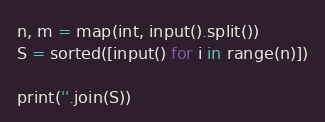Convert code to text. <code><loc_0><loc_0><loc_500><loc_500><_Python_>n, m = map(int, input().split())
S = sorted([input() for i in range(n)])

print(''.join(S))</code> 